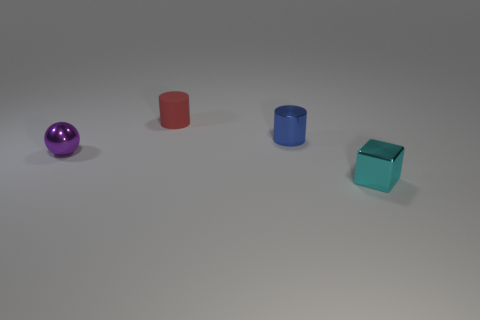Are there any other things that have the same material as the red cylinder?
Your response must be concise. No. Is the number of things that are on the left side of the tiny rubber cylinder greater than the number of big cyan things?
Offer a terse response. Yes. Is there anything else that has the same shape as the cyan object?
Offer a terse response. No. There is another object that is the same shape as the red thing; what is its color?
Give a very brief answer. Blue. What shape is the tiny metallic thing that is to the left of the small metal cylinder?
Offer a very short reply. Sphere. There is a purple thing; are there any rubber things left of it?
Your response must be concise. No. What is the color of the cube that is the same material as the tiny blue object?
Provide a succinct answer. Cyan. How many cylinders are either matte things or small purple objects?
Offer a very short reply. 1. Is the number of blue cylinders that are in front of the shiny cylinder the same as the number of cyan metal things?
Offer a terse response. No. There is a cylinder that is on the left side of the metallic thing behind the tiny shiny thing that is on the left side of the red matte thing; what is its material?
Provide a succinct answer. Rubber. 